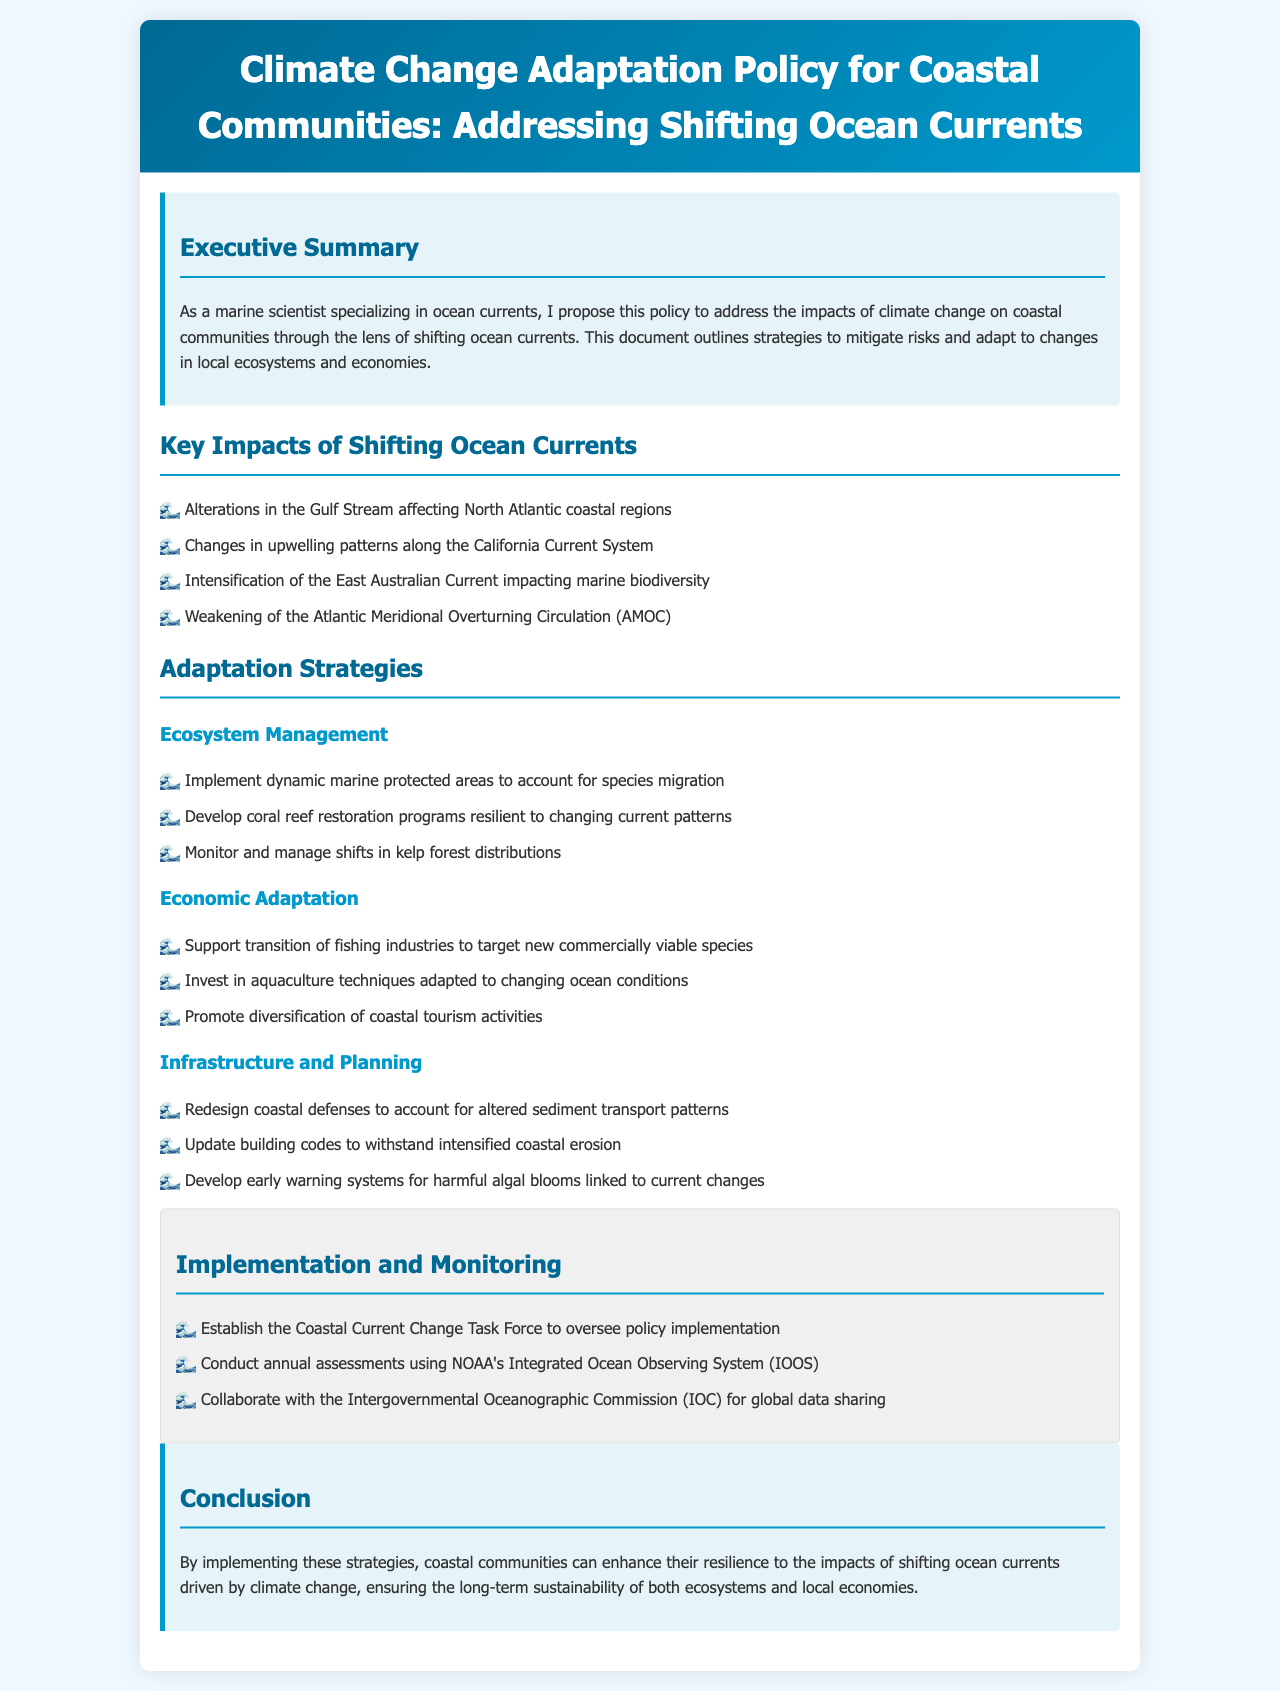What is the title of the policy document? The title is clearly stated at the top of the document, indicating the focus on climate change adaptation for coastal communities.
Answer: Climate Change Adaptation Policy for Coastal Communities: Addressing Shifting Ocean Currents Who oversees the implementation of the policy? The document specifies the establishment of a task force to oversee policy implementation.
Answer: Coastal Current Change Task Force What major ocean current is mentioned to affect North Atlantic coastal regions? Specific ocean currents are listed as key impacts, one of which impacts the North Atlantic region.
Answer: Gulf Stream What type of systems should be developed for harmful algal blooms? This refers to the monitoring and management of algal blooms due to changing conditions outlined in the infrastructure section.
Answer: Early warning systems How many strategies are summarized under Economic Adaptation? The document lists several approaches to economic adaptation, and for economic strategies, quantifying them is straightforward.
Answer: Three Which organization collaborates for global data sharing? The collaboration for data sharing is supported by a known international organization mentioned in the implementation section.
Answer: Intergovernmental Oceanographic Commission What is the main goal of the adaptation strategies? The purpose of all strategies discussed is to ensure sustainability and resilience against specific challenges faced by coastal communities.
Answer: Enhance resilience What is one strategy proposed for ecosystem management? A specific strategy under ecosystem management is mentioned that involves conserving marine areas to adapt to changes.
Answer: Dynamic marine protected areas 